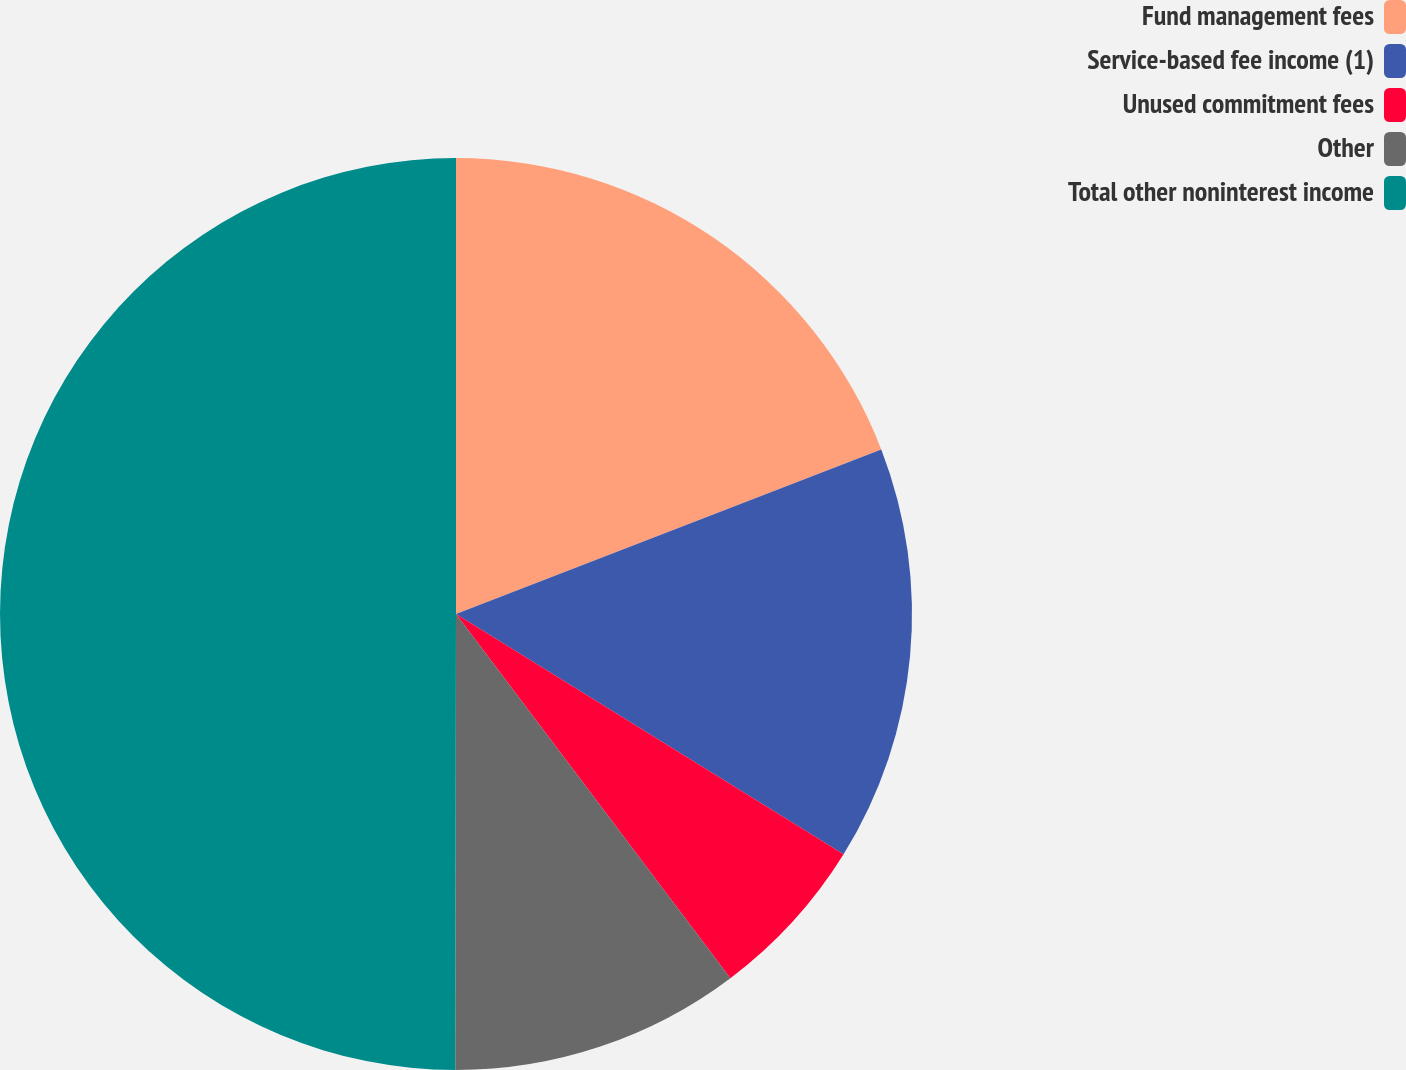Convert chart. <chart><loc_0><loc_0><loc_500><loc_500><pie_chart><fcel>Fund management fees<fcel>Service-based fee income (1)<fcel>Unused commitment fees<fcel>Other<fcel>Total other noninterest income<nl><fcel>19.12%<fcel>14.71%<fcel>5.89%<fcel>10.3%<fcel>49.97%<nl></chart> 